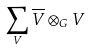Convert formula to latex. <formula><loc_0><loc_0><loc_500><loc_500>\sum _ { V } \overline { V } \otimes _ { G } V</formula> 